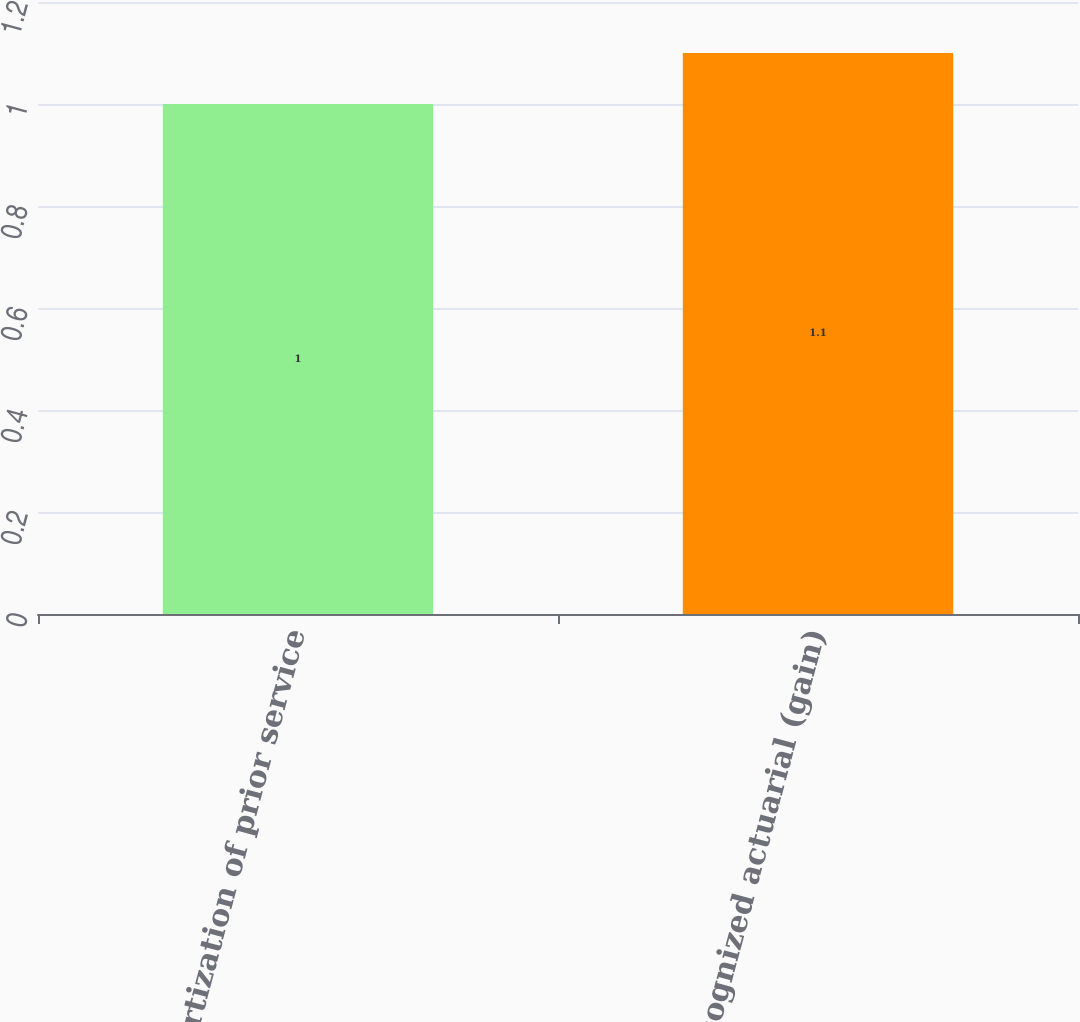Convert chart. <chart><loc_0><loc_0><loc_500><loc_500><bar_chart><fcel>Amortization of prior service<fcel>Recognized actuarial (gain)<nl><fcel>1<fcel>1.1<nl></chart> 